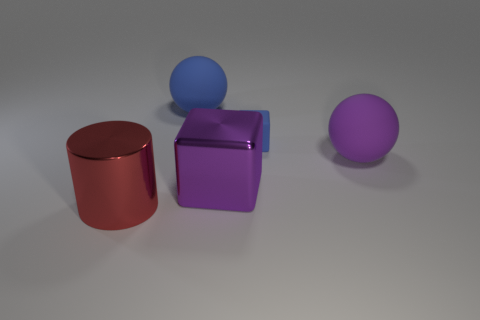Are there any other things that have the same color as the cylinder?
Ensure brevity in your answer.  No. There is a big purple thing that is on the right side of the metallic object that is on the right side of the red metallic thing; how many rubber things are left of it?
Give a very brief answer. 2. Are there an equal number of cylinders on the right side of the big blue matte ball and small blue matte objects that are in front of the matte cube?
Provide a succinct answer. Yes. What number of small objects have the same shape as the large purple metal object?
Give a very brief answer. 1. Is there a large purple object that has the same material as the cylinder?
Ensure brevity in your answer.  Yes. There is a large thing that is the same color as the rubber block; what is its shape?
Provide a short and direct response. Sphere. How many tiny objects are there?
Offer a terse response. 1. How many cylinders are either yellow metal objects or small objects?
Your response must be concise. 0. What color is the metal cube that is the same size as the red object?
Provide a succinct answer. Purple. What number of matte objects are behind the purple matte thing and to the right of the large blue ball?
Give a very brief answer. 1. 